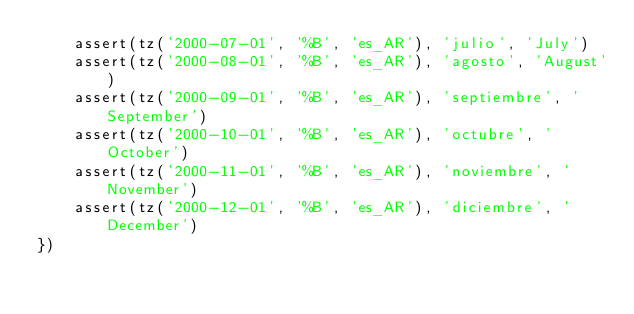Convert code to text. <code><loc_0><loc_0><loc_500><loc_500><_JavaScript_>    assert(tz('2000-07-01', '%B', 'es_AR'), 'julio', 'July')
    assert(tz('2000-08-01', '%B', 'es_AR'), 'agosto', 'August')
    assert(tz('2000-09-01', '%B', 'es_AR'), 'septiembre', 'September')
    assert(tz('2000-10-01', '%B', 'es_AR'), 'octubre', 'October')
    assert(tz('2000-11-01', '%B', 'es_AR'), 'noviembre', 'November')
    assert(tz('2000-12-01', '%B', 'es_AR'), 'diciembre', 'December')
})
</code> 